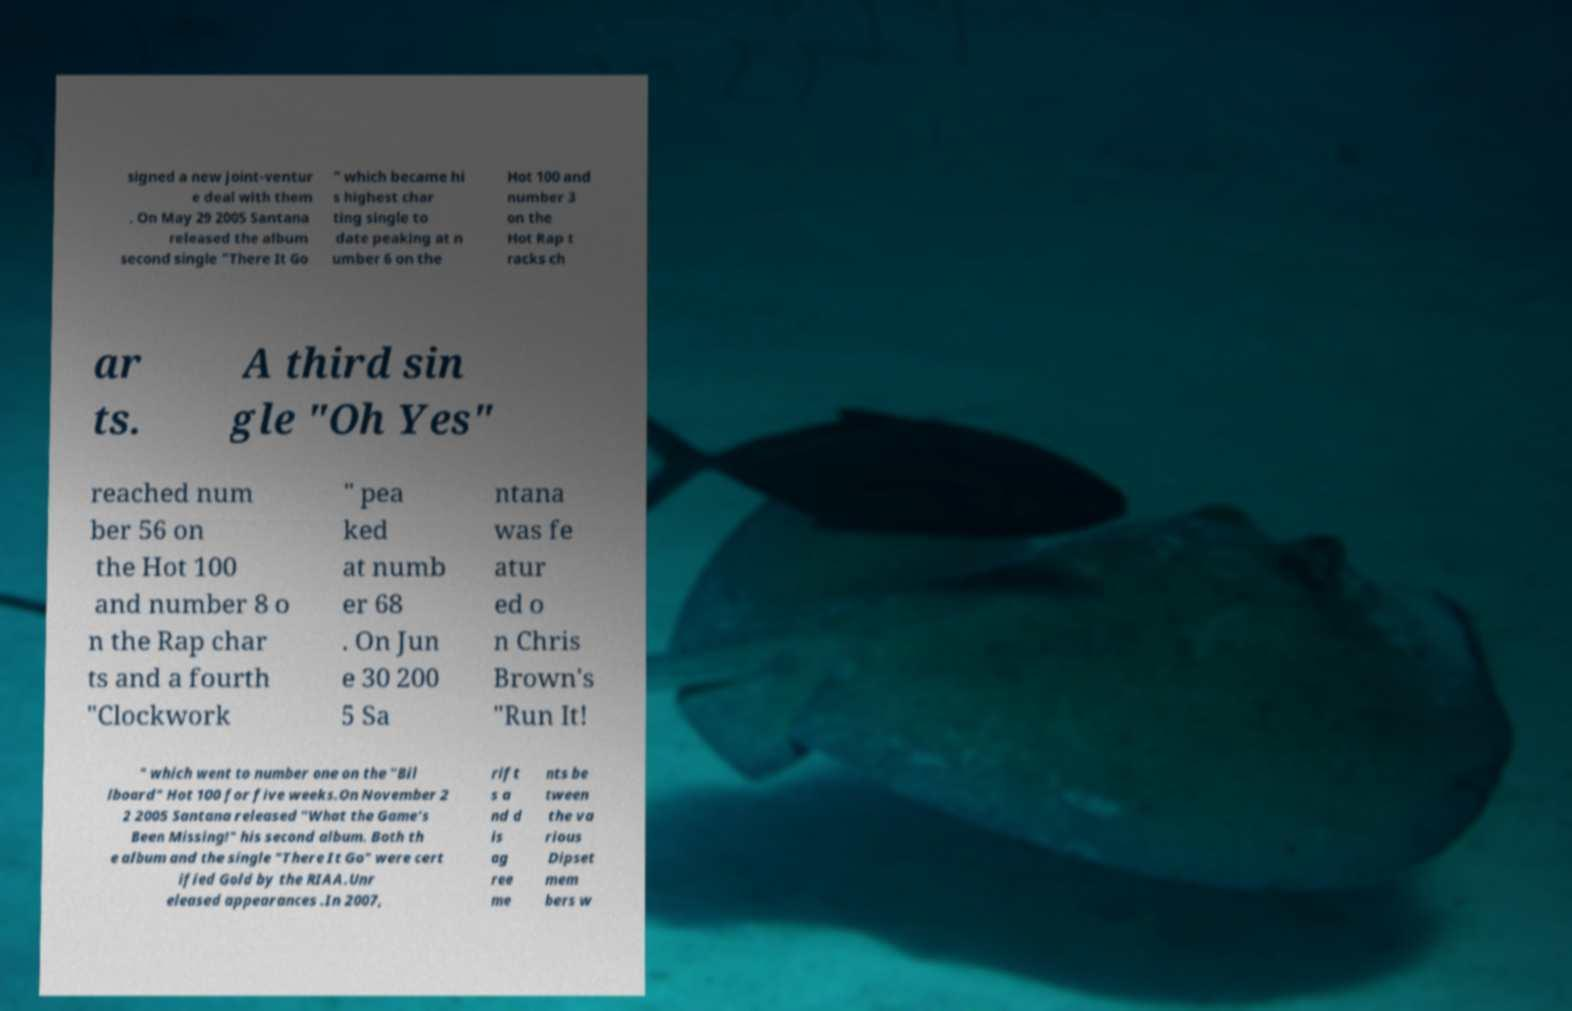Could you assist in decoding the text presented in this image and type it out clearly? signed a new joint-ventur e deal with them . On May 29 2005 Santana released the album second single "There It Go " which became hi s highest char ting single to date peaking at n umber 6 on the Hot 100 and number 3 on the Hot Rap t racks ch ar ts. A third sin gle "Oh Yes" reached num ber 56 on the Hot 100 and number 8 o n the Rap char ts and a fourth "Clockwork " pea ked at numb er 68 . On Jun e 30 200 5 Sa ntana was fe atur ed o n Chris Brown's "Run It! " which went to number one on the "Bil lboard" Hot 100 for five weeks.On November 2 2 2005 Santana released "What the Game's Been Missing!" his second album. Both th e album and the single "There It Go" were cert ified Gold by the RIAA.Unr eleased appearances .In 2007, rift s a nd d is ag ree me nts be tween the va rious Dipset mem bers w 